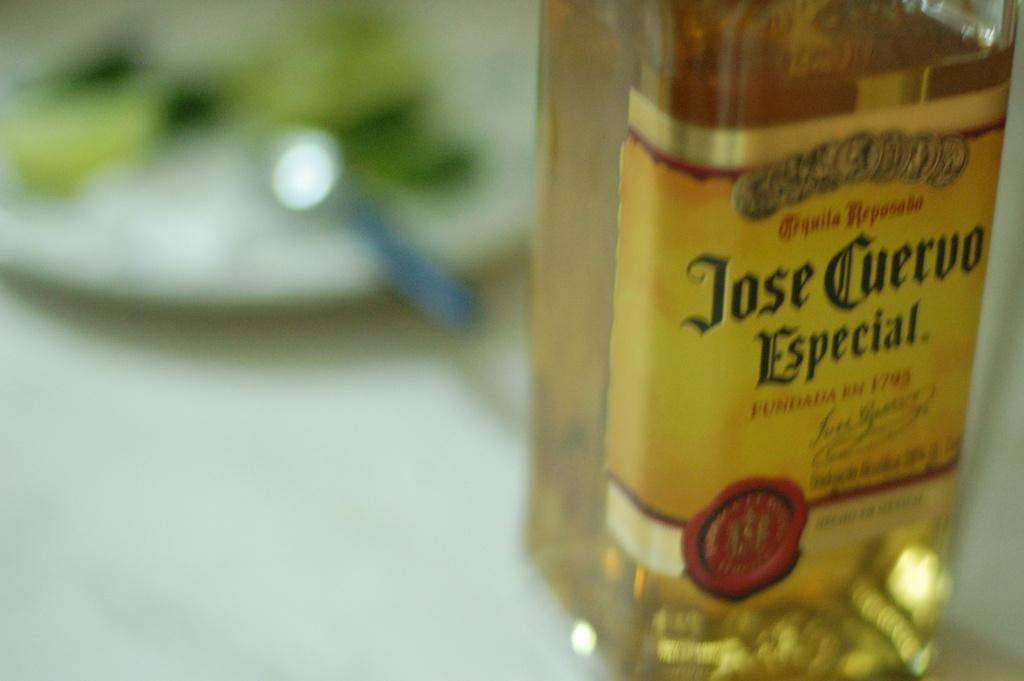<image>
Provide a brief description of the given image. a bottle of jose cuervo especial founded in 1795 